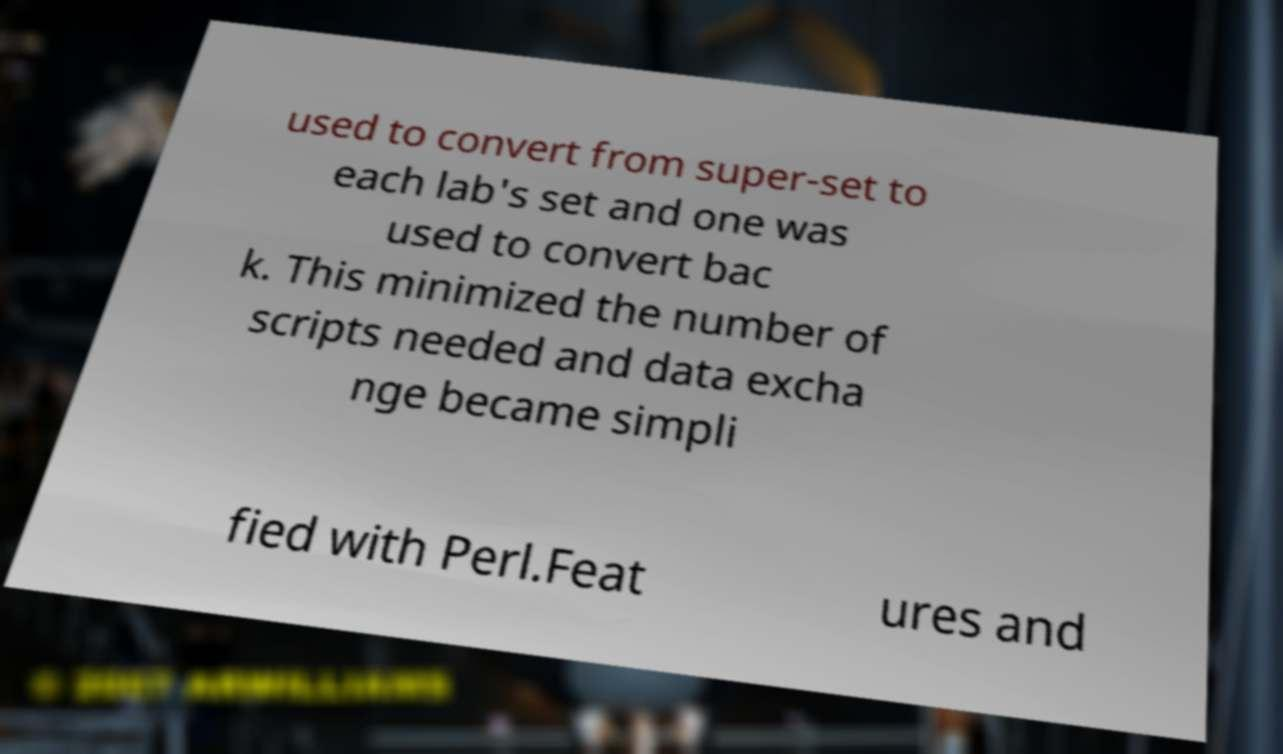Could you extract and type out the text from this image? used to convert from super-set to each lab's set and one was used to convert bac k. This minimized the number of scripts needed and data excha nge became simpli fied with Perl.Feat ures and 